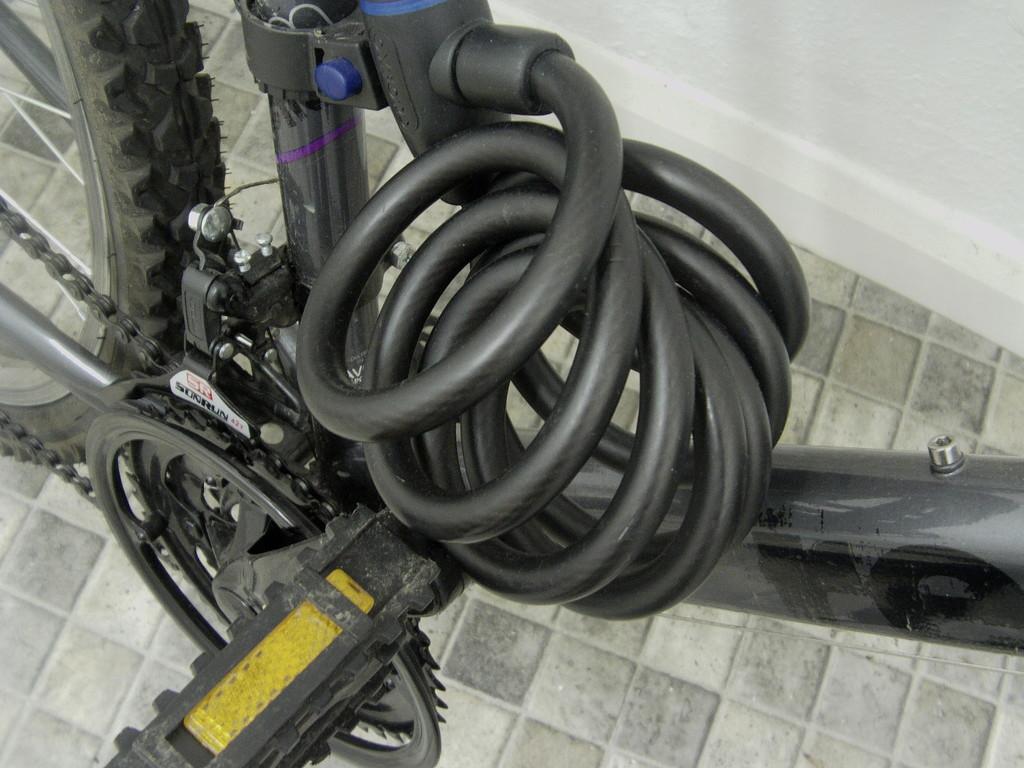Please provide a concise description of this image. In this image, there is a cycle and on the left side there is a chair and at the top left side corner there is a tier. 